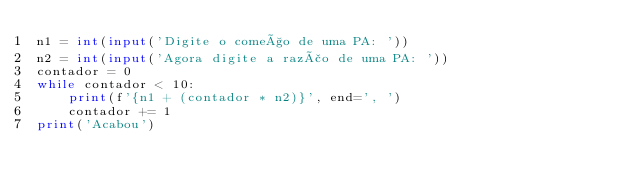Convert code to text. <code><loc_0><loc_0><loc_500><loc_500><_Python_>n1 = int(input('Digite o começo de uma PA: '))
n2 = int(input('Agora digite a razão de uma PA: '))
contador = 0
while contador < 10:
    print(f'{n1 + (contador * n2)}', end=', ')
    contador += 1
print('Acabou')
</code> 